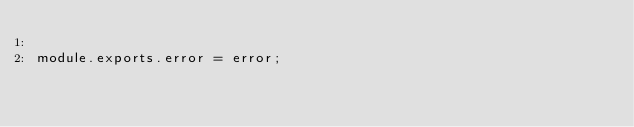Convert code to text. <code><loc_0><loc_0><loc_500><loc_500><_JavaScript_>
module.exports.error = error;
</code> 